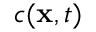<formula> <loc_0><loc_0><loc_500><loc_500>c ( x , t )</formula> 